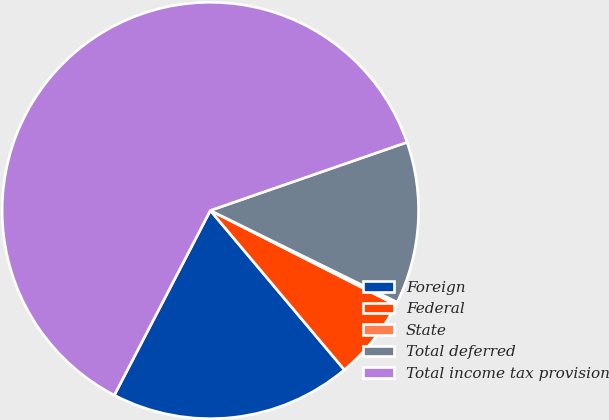<chart> <loc_0><loc_0><loc_500><loc_500><pie_chart><fcel>Foreign<fcel>Federal<fcel>State<fcel>Total deferred<fcel>Total income tax provision<nl><fcel>18.76%<fcel>6.39%<fcel>0.21%<fcel>12.58%<fcel>62.05%<nl></chart> 